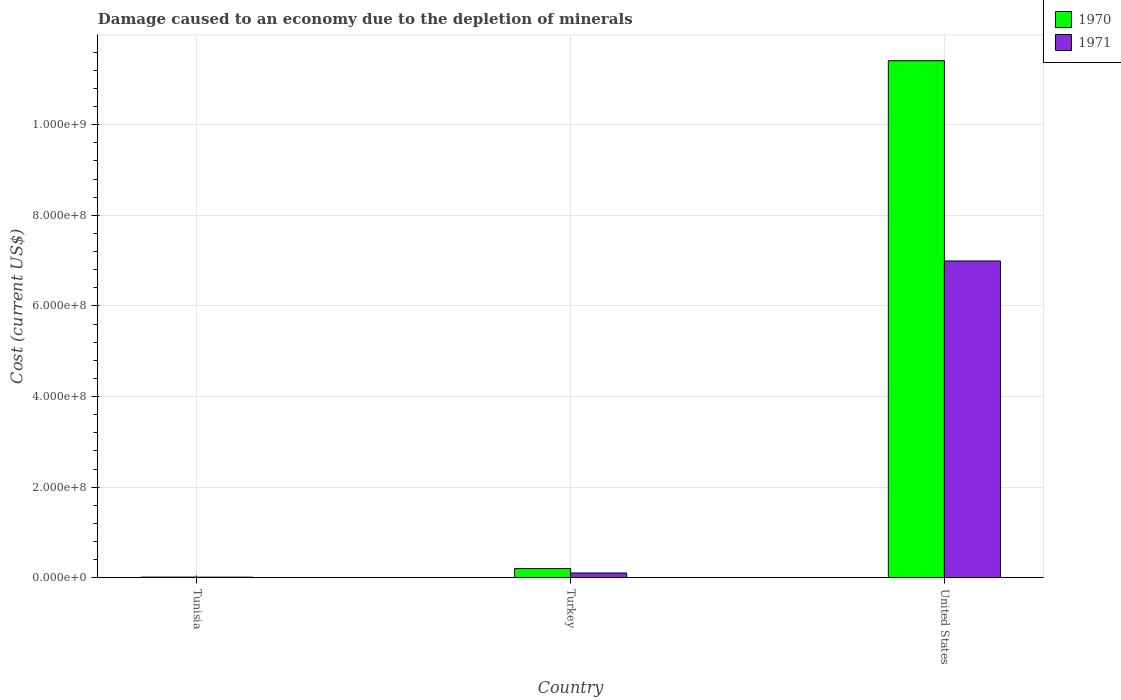How many different coloured bars are there?
Provide a succinct answer. 2. How many groups of bars are there?
Provide a short and direct response. 3. Are the number of bars per tick equal to the number of legend labels?
Make the answer very short. Yes. How many bars are there on the 2nd tick from the left?
Offer a very short reply. 2. What is the label of the 1st group of bars from the left?
Your answer should be very brief. Tunisia. In how many cases, is the number of bars for a given country not equal to the number of legend labels?
Your answer should be compact. 0. What is the cost of damage caused due to the depletion of minerals in 1970 in Turkey?
Give a very brief answer. 2.02e+07. Across all countries, what is the maximum cost of damage caused due to the depletion of minerals in 1971?
Offer a very short reply. 6.99e+08. Across all countries, what is the minimum cost of damage caused due to the depletion of minerals in 1970?
Ensure brevity in your answer.  1.33e+06. In which country was the cost of damage caused due to the depletion of minerals in 1971 maximum?
Give a very brief answer. United States. In which country was the cost of damage caused due to the depletion of minerals in 1970 minimum?
Offer a terse response. Tunisia. What is the total cost of damage caused due to the depletion of minerals in 1970 in the graph?
Make the answer very short. 1.16e+09. What is the difference between the cost of damage caused due to the depletion of minerals in 1970 in Tunisia and that in Turkey?
Make the answer very short. -1.88e+07. What is the difference between the cost of damage caused due to the depletion of minerals in 1970 in Turkey and the cost of damage caused due to the depletion of minerals in 1971 in United States?
Your answer should be compact. -6.79e+08. What is the average cost of damage caused due to the depletion of minerals in 1970 per country?
Provide a succinct answer. 3.88e+08. What is the difference between the cost of damage caused due to the depletion of minerals of/in 1971 and cost of damage caused due to the depletion of minerals of/in 1970 in Turkey?
Offer a terse response. -9.76e+06. In how many countries, is the cost of damage caused due to the depletion of minerals in 1971 greater than 1080000000 US$?
Provide a short and direct response. 0. What is the ratio of the cost of damage caused due to the depletion of minerals in 1970 in Tunisia to that in United States?
Ensure brevity in your answer.  0. Is the cost of damage caused due to the depletion of minerals in 1971 in Turkey less than that in United States?
Provide a short and direct response. Yes. Is the difference between the cost of damage caused due to the depletion of minerals in 1971 in Tunisia and Turkey greater than the difference between the cost of damage caused due to the depletion of minerals in 1970 in Tunisia and Turkey?
Give a very brief answer. Yes. What is the difference between the highest and the second highest cost of damage caused due to the depletion of minerals in 1970?
Keep it short and to the point. -1.12e+09. What is the difference between the highest and the lowest cost of damage caused due to the depletion of minerals in 1971?
Keep it short and to the point. 6.98e+08. What does the 2nd bar from the right in Tunisia represents?
Your response must be concise. 1970. Are all the bars in the graph horizontal?
Your answer should be very brief. No. How many countries are there in the graph?
Make the answer very short. 3. Are the values on the major ticks of Y-axis written in scientific E-notation?
Make the answer very short. Yes. Does the graph contain grids?
Your response must be concise. Yes. How many legend labels are there?
Your answer should be very brief. 2. What is the title of the graph?
Ensure brevity in your answer.  Damage caused to an economy due to the depletion of minerals. Does "1961" appear as one of the legend labels in the graph?
Offer a very short reply. No. What is the label or title of the X-axis?
Keep it short and to the point. Country. What is the label or title of the Y-axis?
Offer a terse response. Cost (current US$). What is the Cost (current US$) of 1970 in Tunisia?
Offer a very short reply. 1.33e+06. What is the Cost (current US$) in 1971 in Tunisia?
Give a very brief answer. 1.21e+06. What is the Cost (current US$) in 1970 in Turkey?
Your answer should be very brief. 2.02e+07. What is the Cost (current US$) of 1971 in Turkey?
Offer a terse response. 1.04e+07. What is the Cost (current US$) of 1970 in United States?
Offer a very short reply. 1.14e+09. What is the Cost (current US$) of 1971 in United States?
Provide a short and direct response. 6.99e+08. Across all countries, what is the maximum Cost (current US$) of 1970?
Give a very brief answer. 1.14e+09. Across all countries, what is the maximum Cost (current US$) of 1971?
Provide a short and direct response. 6.99e+08. Across all countries, what is the minimum Cost (current US$) in 1970?
Your answer should be compact. 1.33e+06. Across all countries, what is the minimum Cost (current US$) in 1971?
Your answer should be compact. 1.21e+06. What is the total Cost (current US$) of 1970 in the graph?
Your response must be concise. 1.16e+09. What is the total Cost (current US$) in 1971 in the graph?
Your answer should be compact. 7.11e+08. What is the difference between the Cost (current US$) of 1970 in Tunisia and that in Turkey?
Your response must be concise. -1.88e+07. What is the difference between the Cost (current US$) in 1971 in Tunisia and that in Turkey?
Offer a terse response. -9.18e+06. What is the difference between the Cost (current US$) of 1970 in Tunisia and that in United States?
Provide a short and direct response. -1.14e+09. What is the difference between the Cost (current US$) in 1971 in Tunisia and that in United States?
Your answer should be very brief. -6.98e+08. What is the difference between the Cost (current US$) of 1970 in Turkey and that in United States?
Ensure brevity in your answer.  -1.12e+09. What is the difference between the Cost (current US$) of 1971 in Turkey and that in United States?
Give a very brief answer. -6.89e+08. What is the difference between the Cost (current US$) of 1970 in Tunisia and the Cost (current US$) of 1971 in Turkey?
Your answer should be very brief. -9.07e+06. What is the difference between the Cost (current US$) in 1970 in Tunisia and the Cost (current US$) in 1971 in United States?
Give a very brief answer. -6.98e+08. What is the difference between the Cost (current US$) in 1970 in Turkey and the Cost (current US$) in 1971 in United States?
Offer a very short reply. -6.79e+08. What is the average Cost (current US$) in 1970 per country?
Offer a very short reply. 3.88e+08. What is the average Cost (current US$) of 1971 per country?
Give a very brief answer. 2.37e+08. What is the difference between the Cost (current US$) in 1970 and Cost (current US$) in 1971 in Tunisia?
Your response must be concise. 1.16e+05. What is the difference between the Cost (current US$) in 1970 and Cost (current US$) in 1971 in Turkey?
Offer a very short reply. 9.76e+06. What is the difference between the Cost (current US$) of 1970 and Cost (current US$) of 1971 in United States?
Offer a terse response. 4.42e+08. What is the ratio of the Cost (current US$) in 1970 in Tunisia to that in Turkey?
Make the answer very short. 0.07. What is the ratio of the Cost (current US$) in 1971 in Tunisia to that in Turkey?
Your answer should be compact. 0.12. What is the ratio of the Cost (current US$) in 1970 in Tunisia to that in United States?
Your answer should be very brief. 0. What is the ratio of the Cost (current US$) of 1971 in Tunisia to that in United States?
Your response must be concise. 0. What is the ratio of the Cost (current US$) in 1970 in Turkey to that in United States?
Give a very brief answer. 0.02. What is the ratio of the Cost (current US$) of 1971 in Turkey to that in United States?
Provide a short and direct response. 0.01. What is the difference between the highest and the second highest Cost (current US$) in 1970?
Your response must be concise. 1.12e+09. What is the difference between the highest and the second highest Cost (current US$) in 1971?
Make the answer very short. 6.89e+08. What is the difference between the highest and the lowest Cost (current US$) of 1970?
Offer a terse response. 1.14e+09. What is the difference between the highest and the lowest Cost (current US$) of 1971?
Make the answer very short. 6.98e+08. 